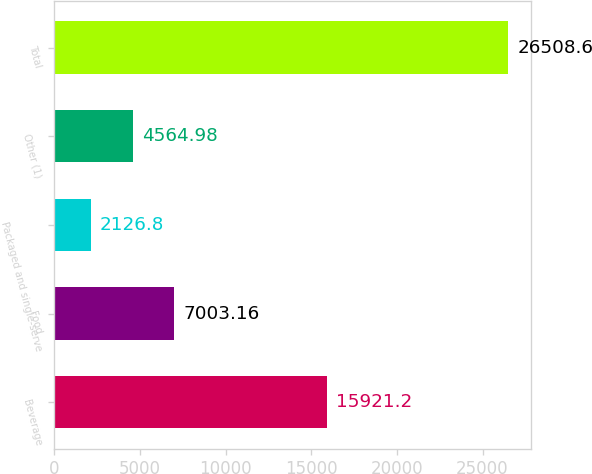<chart> <loc_0><loc_0><loc_500><loc_500><bar_chart><fcel>Beverage<fcel>Food<fcel>Packaged and single-serve<fcel>Other (1)<fcel>Total<nl><fcel>15921.2<fcel>7003.16<fcel>2126.8<fcel>4564.98<fcel>26508.6<nl></chart> 